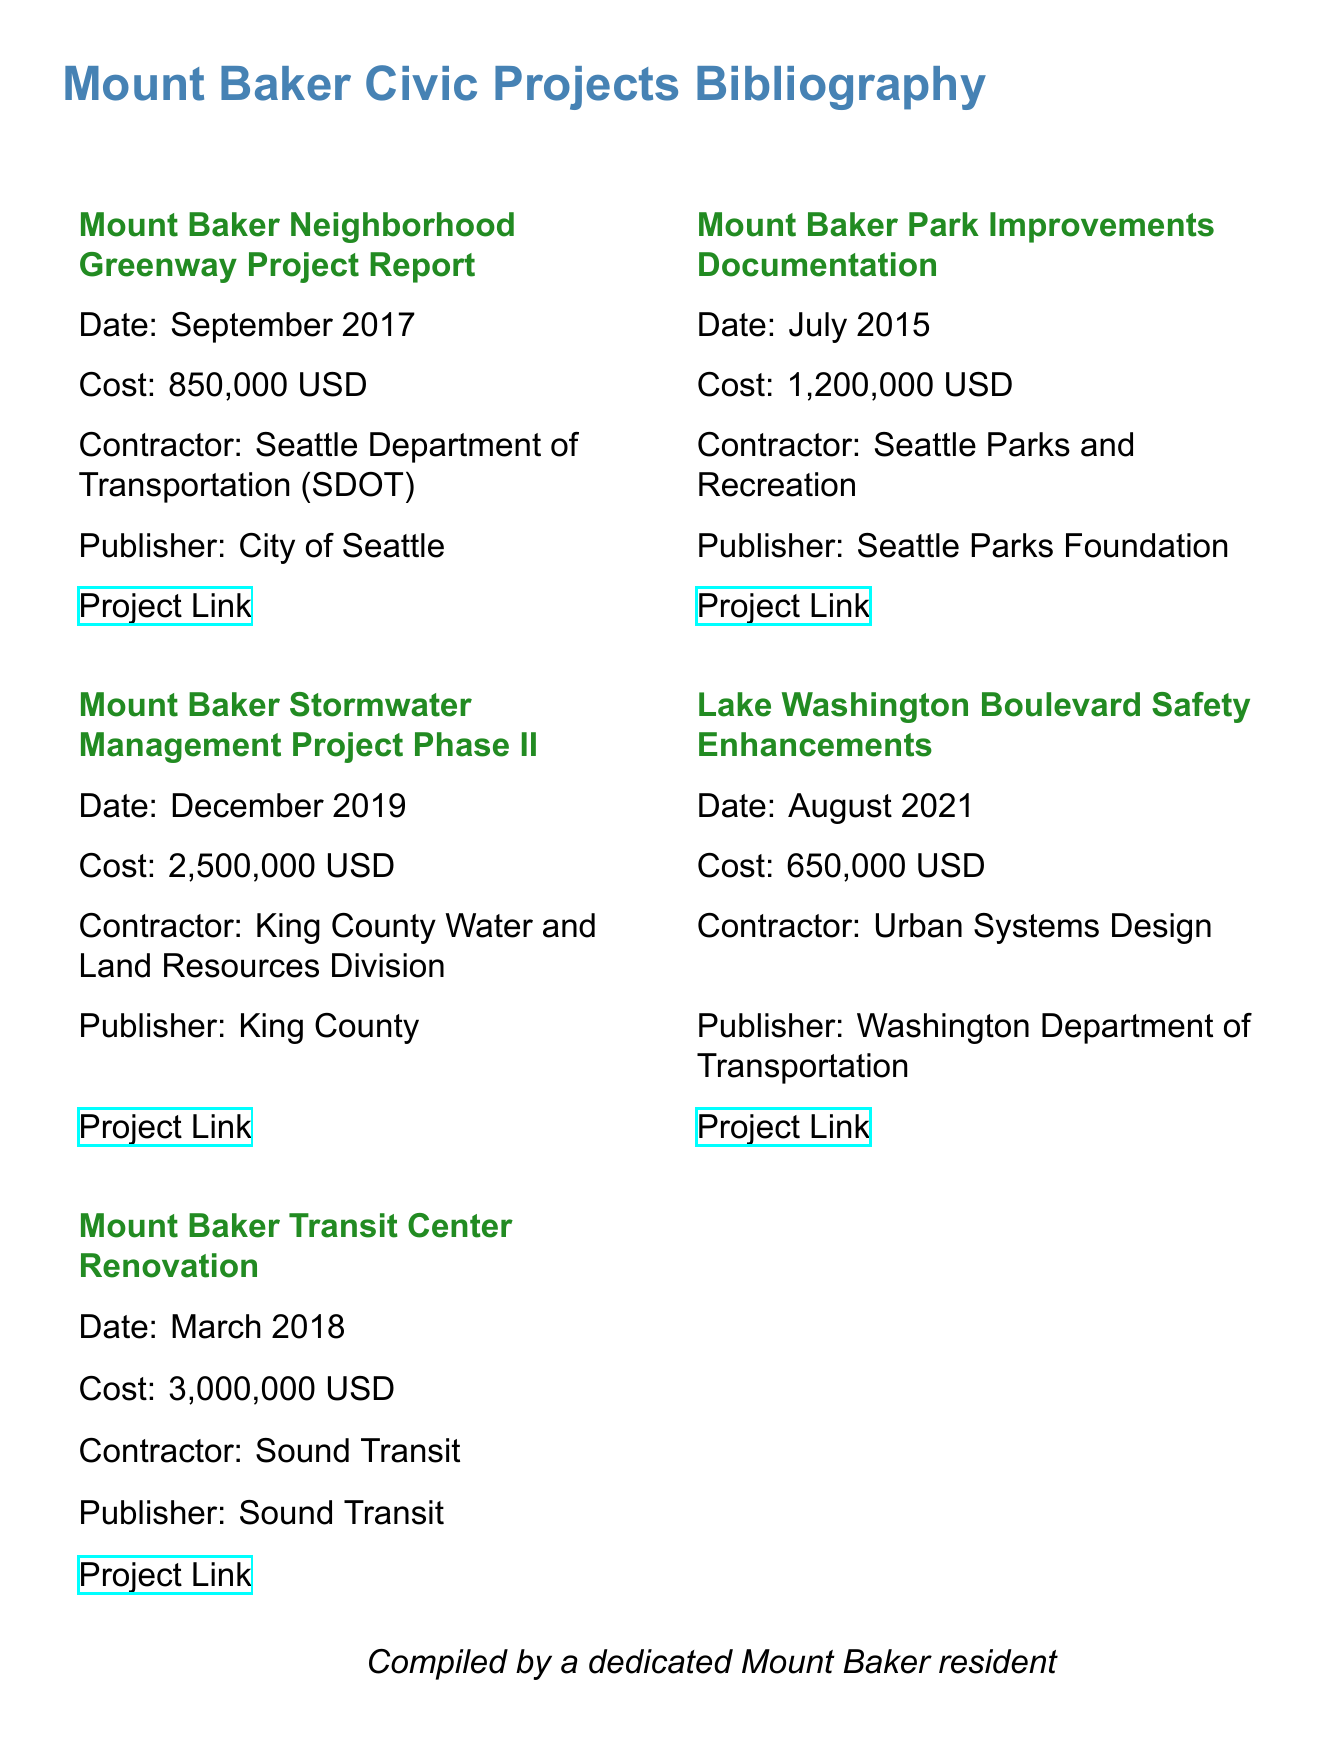What is the cost of the Mount Baker Neighborhood Greenway Project? The cost of the Mount Baker Neighborhood Greenway Project is explicitly mentioned in the document.
Answer: 850,000 USD Who was the contractor for the Mount Baker Park Improvements? The document lists the contractor involved with the Mount Baker Park Improvements project.
Answer: Seattle Parks and Recreation What date was the Mount Baker Stormwater Management Project Phase II completed? The completion date is provided for the Mount Baker Stormwater Management Project Phase II in the document.
Answer: December 2019 Which project had the highest cost? To determine this, one must compare the costs listed for each project in the document.
Answer: Mount Baker Transit Center Renovation What organization published the documentation for the Lake Washington Boulevard Safety Enhancements? The document indicates the publisher for the Lake Washington Boulevard Safety Enhancements project.
Answer: Washington Department of Transportation 